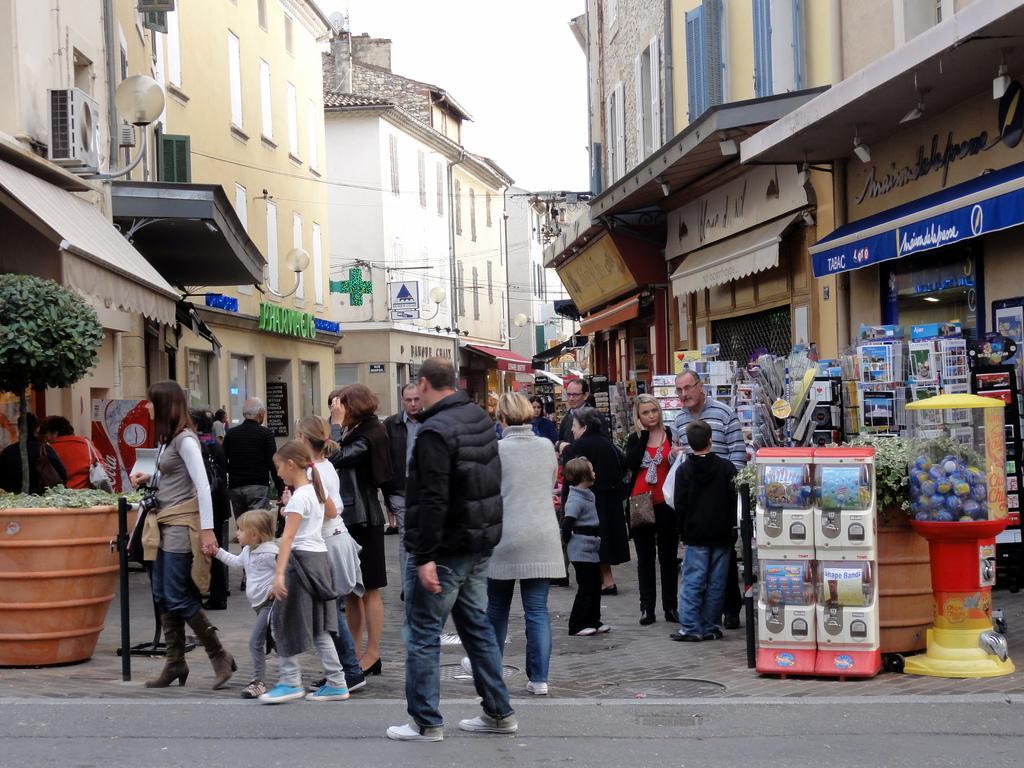Could you give a brief overview of what you see in this image? There are persons in different color dresses walking on the road. On both sides of this road, there are buildings, pot plants and hoardings. On the right side, there are some objects on the footpath. In the background, there is sky. 